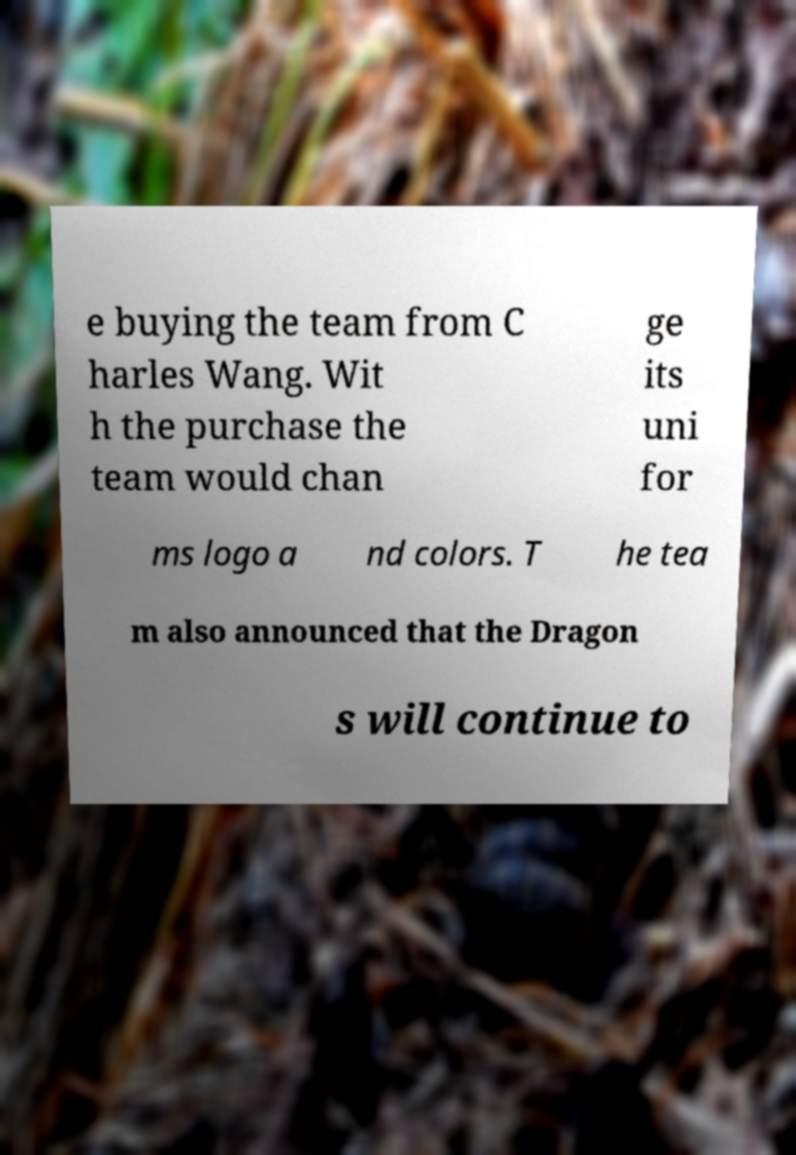Could you extract and type out the text from this image? e buying the team from C harles Wang. Wit h the purchase the team would chan ge its uni for ms logo a nd colors. T he tea m also announced that the Dragon s will continue to 